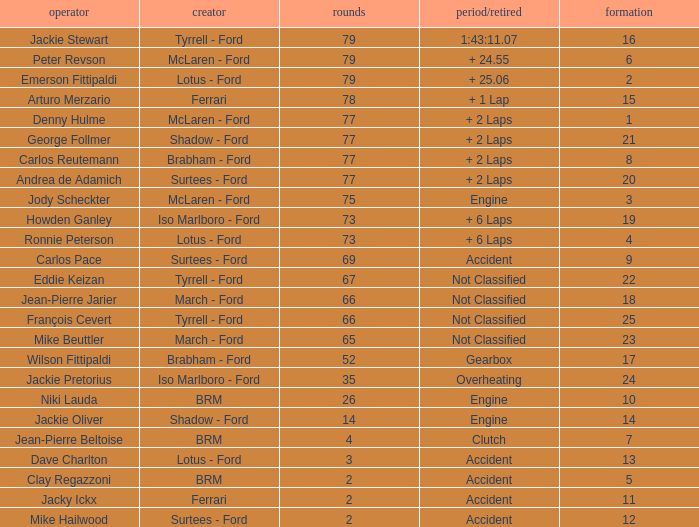What is the total grid with laps less than 2? None. 